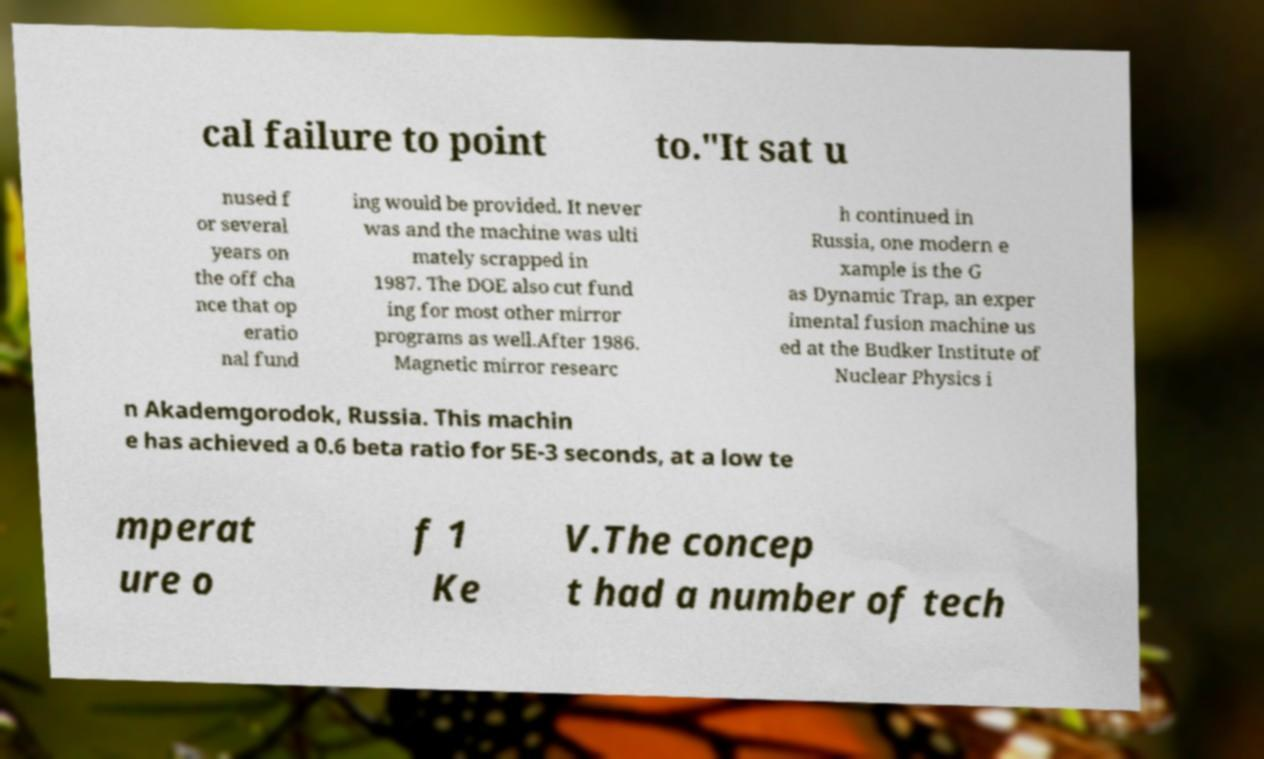Could you assist in decoding the text presented in this image and type it out clearly? cal failure to point to."It sat u nused f or several years on the off cha nce that op eratio nal fund ing would be provided. It never was and the machine was ulti mately scrapped in 1987. The DOE also cut fund ing for most other mirror programs as well.After 1986. Magnetic mirror researc h continued in Russia, one modern e xample is the G as Dynamic Trap, an exper imental fusion machine us ed at the Budker Institute of Nuclear Physics i n Akademgorodok, Russia. This machin e has achieved a 0.6 beta ratio for 5E-3 seconds, at a low te mperat ure o f 1 Ke V.The concep t had a number of tech 